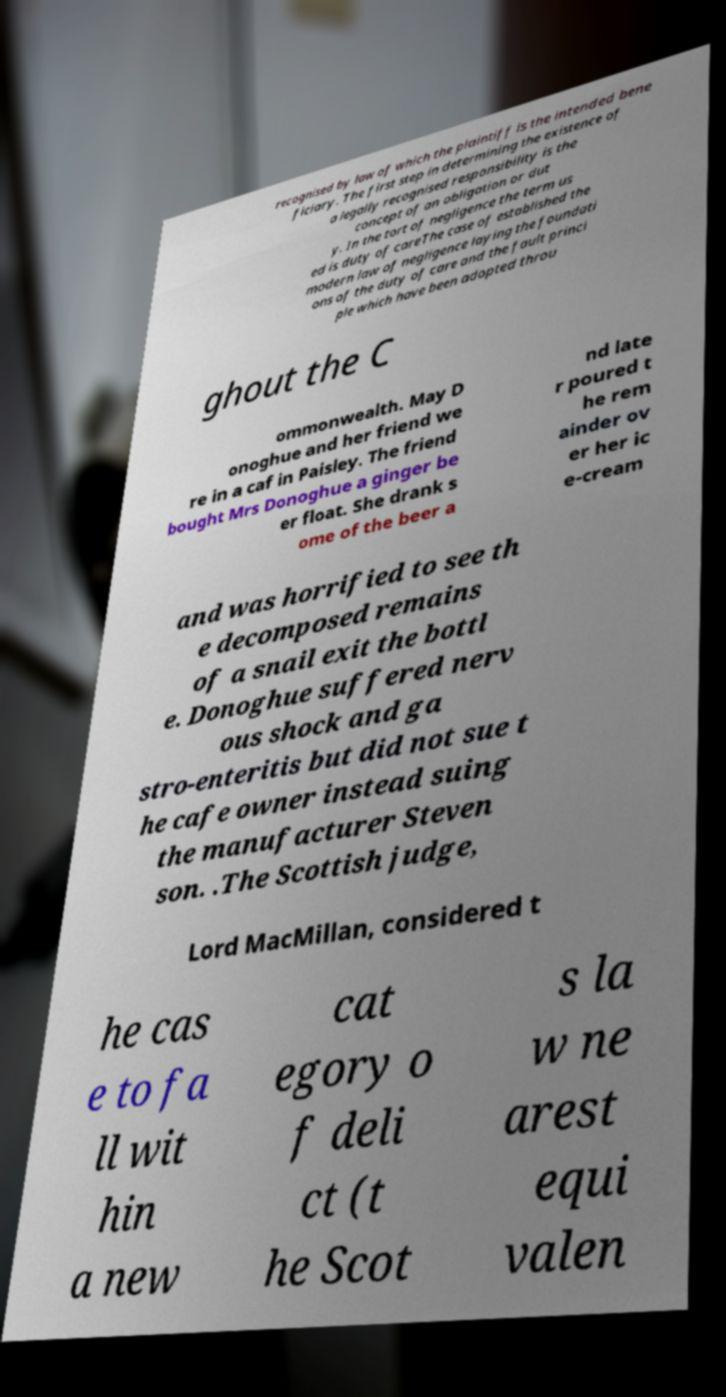Could you assist in decoding the text presented in this image and type it out clearly? recognised by law of which the plaintiff is the intended bene ficiary. The first step in determining the existence of a legally recognised responsibility is the concept of an obligation or dut y. In the tort of negligence the term us ed is duty of careThe case of established the modern law of negligence laying the foundati ons of the duty of care and the fault princi ple which have been adopted throu ghout the C ommonwealth. May D onoghue and her friend we re in a caf in Paisley. The friend bought Mrs Donoghue a ginger be er float. She drank s ome of the beer a nd late r poured t he rem ainder ov er her ic e-cream and was horrified to see th e decomposed remains of a snail exit the bottl e. Donoghue suffered nerv ous shock and ga stro-enteritis but did not sue t he cafe owner instead suing the manufacturer Steven son. .The Scottish judge, Lord MacMillan, considered t he cas e to fa ll wit hin a new cat egory o f deli ct (t he Scot s la w ne arest equi valen 